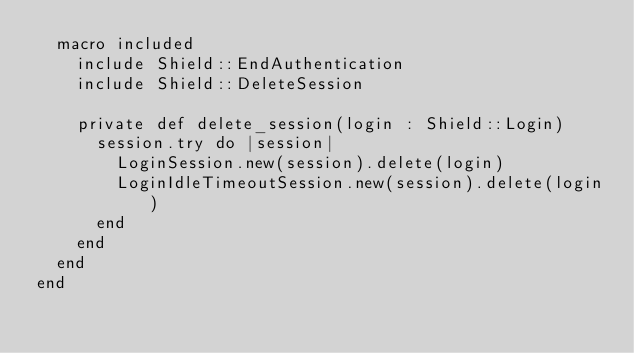Convert code to text. <code><loc_0><loc_0><loc_500><loc_500><_Crystal_>  macro included
    include Shield::EndAuthentication
    include Shield::DeleteSession

    private def delete_session(login : Shield::Login)
      session.try do |session|
        LoginSession.new(session).delete(login)
        LoginIdleTimeoutSession.new(session).delete(login)
      end
    end
  end
end
</code> 